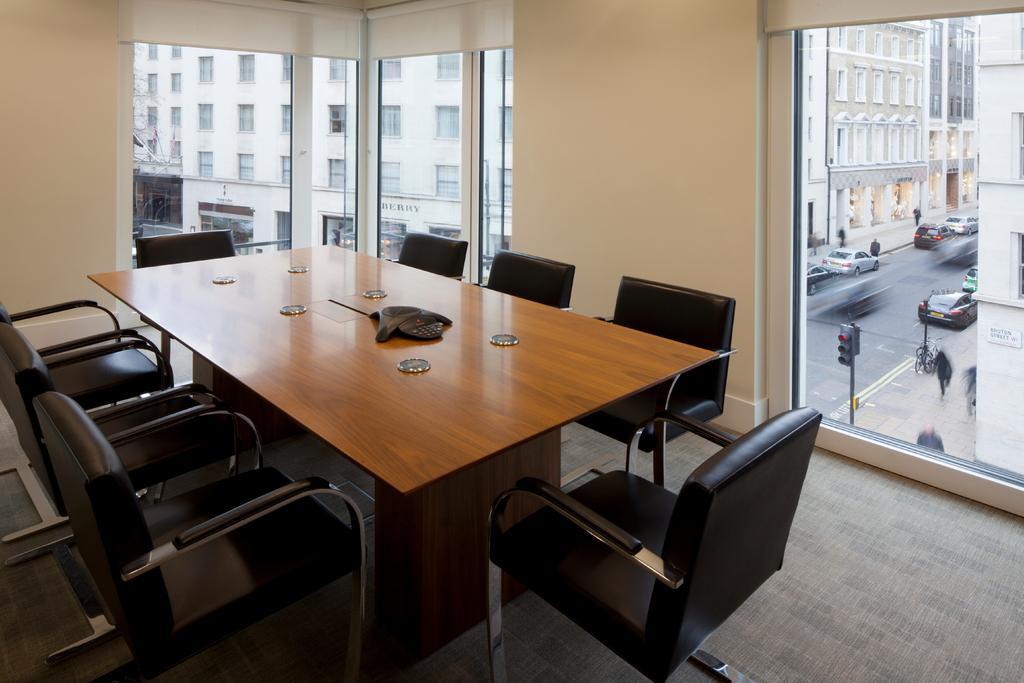Describe this image in one or two sentences. In this picture there is a view of the room. In front we can see wooden table with some chairs. Behind we can see the glass in the wall from which road and some buildings are visible. 